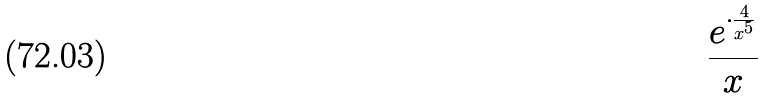<formula> <loc_0><loc_0><loc_500><loc_500>\frac { e ^ { \cdot \frac { 4 } { x ^ { 5 } } } } { x }</formula> 